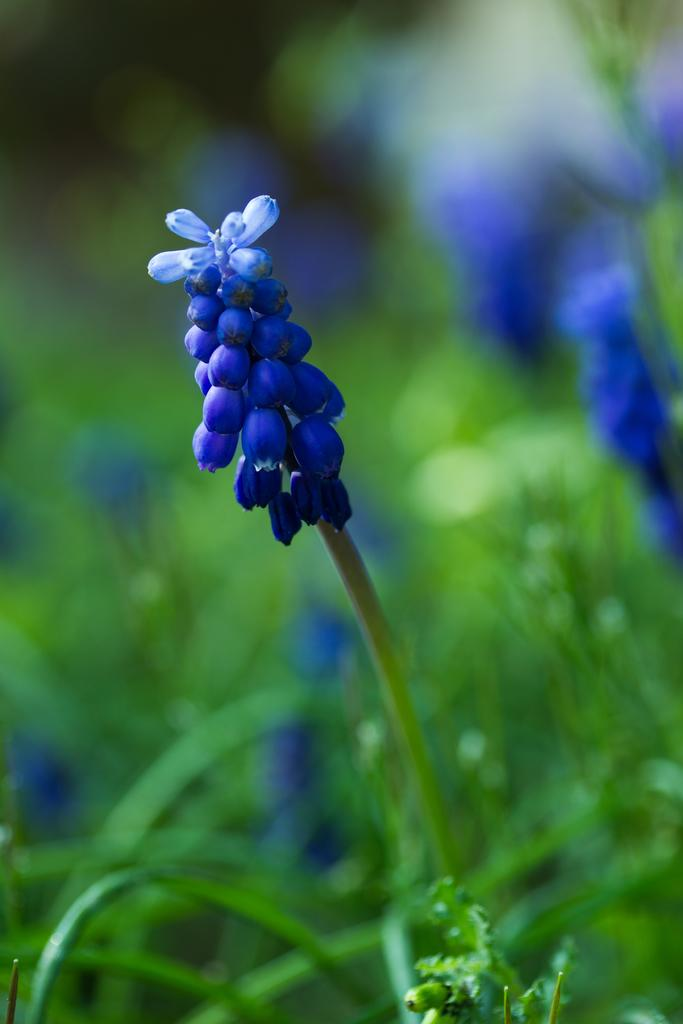What is located in the center of the image? There are plants and flowers in the center of the image. What type of plants are present in the image? The plants and flowers in the image are in dark blue color. Where can the books be found in the image? There are no books present in the image. What type of animal can be seen in the zoo in the image? There is no zoo or animal present in the image. 